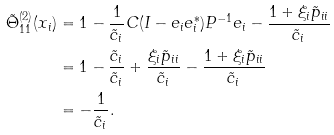<formula> <loc_0><loc_0><loc_500><loc_500>\tilde { \Theta } _ { 1 1 } ^ { ( 2 ) } ( x _ { i } ) & = 1 - \frac { 1 } { \tilde { c } _ { i } } C ( I - e _ { i } e _ { i } ^ { * } ) P ^ { - 1 } e _ { i } - \frac { 1 + \xi _ { i } \tilde { p } _ { i i } } { \tilde { c } _ { i } } \\ & = 1 - \frac { \tilde { c } _ { i } } { \tilde { c } _ { i } } + \frac { \xi _ { i } \tilde { p } _ { i i } } { \tilde { c } _ { i } } - \frac { 1 + \xi _ { i } \tilde { p } _ { i i } } { \tilde { c } _ { i } } \\ & = - \frac { 1 } { \tilde { c } _ { i } } .</formula> 